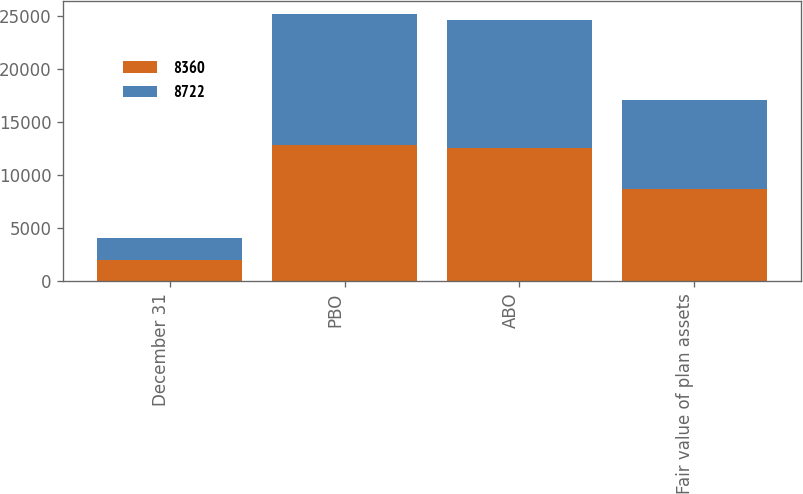<chart> <loc_0><loc_0><loc_500><loc_500><stacked_bar_chart><ecel><fcel>December 31<fcel>PBO<fcel>ABO<fcel>Fair value of plan assets<nl><fcel>8360<fcel>2016<fcel>12817<fcel>12557<fcel>8722<nl><fcel>8722<fcel>2015<fcel>12368<fcel>12082<fcel>8360<nl></chart> 